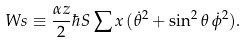Convert formula to latex. <formula><loc_0><loc_0><loc_500><loc_500>\ W s \equiv \frac { \alpha z } { 2 } \hbar { S } \sum x \, ( \dot { \theta } ^ { 2 } + \sin ^ { 2 } \theta \, \dot { \phi } ^ { 2 } ) .</formula> 